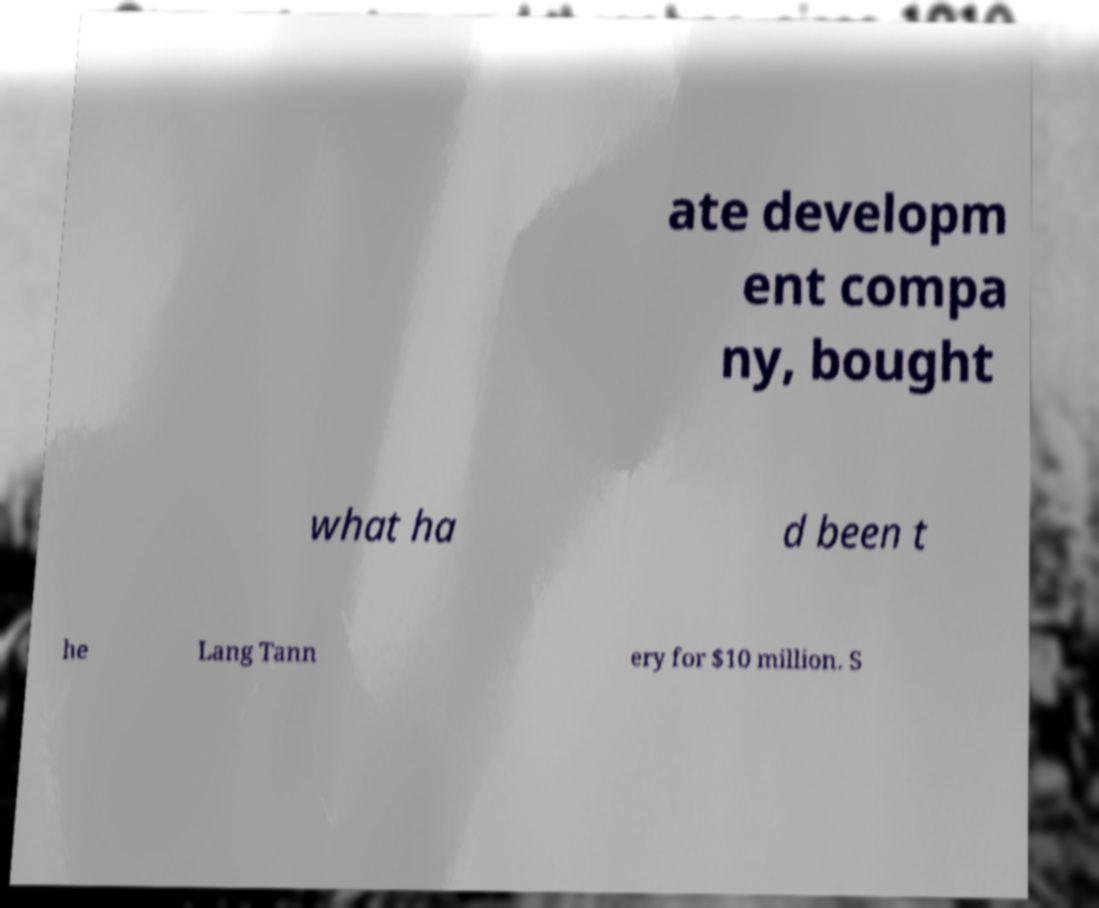I need the written content from this picture converted into text. Can you do that? ate developm ent compa ny, bought what ha d been t he Lang Tann ery for $10 million. S 